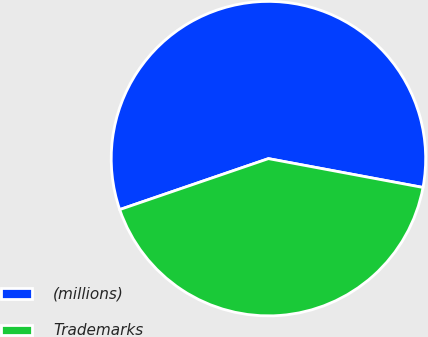Convert chart to OTSL. <chart><loc_0><loc_0><loc_500><loc_500><pie_chart><fcel>(millions)<fcel>Trademarks<nl><fcel>58.19%<fcel>41.81%<nl></chart> 